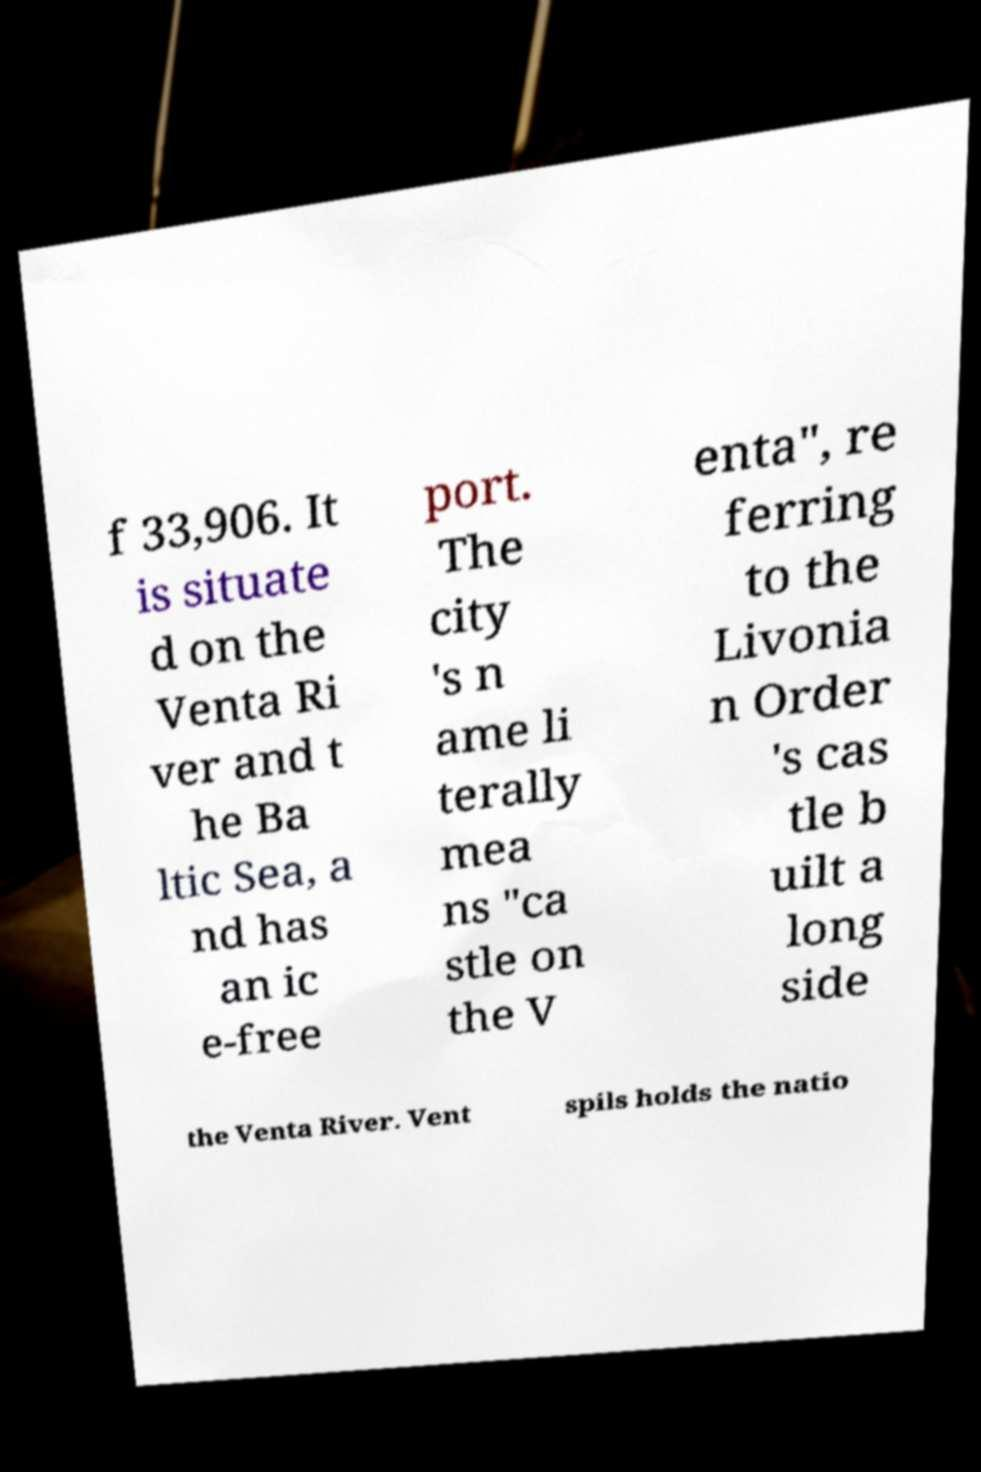Can you read and provide the text displayed in the image?This photo seems to have some interesting text. Can you extract and type it out for me? f 33,906. It is situate d on the Venta Ri ver and t he Ba ltic Sea, a nd has an ic e-free port. The city 's n ame li terally mea ns "ca stle on the V enta", re ferring to the Livonia n Order 's cas tle b uilt a long side the Venta River. Vent spils holds the natio 